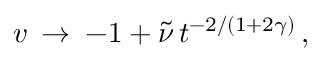Convert formula to latex. <formula><loc_0><loc_0><loc_500><loc_500>v \, \rightarrow \, - 1 + \tilde { \nu } \, t ^ { - 2 / ( 1 + 2 \gamma ) } \, ,</formula> 